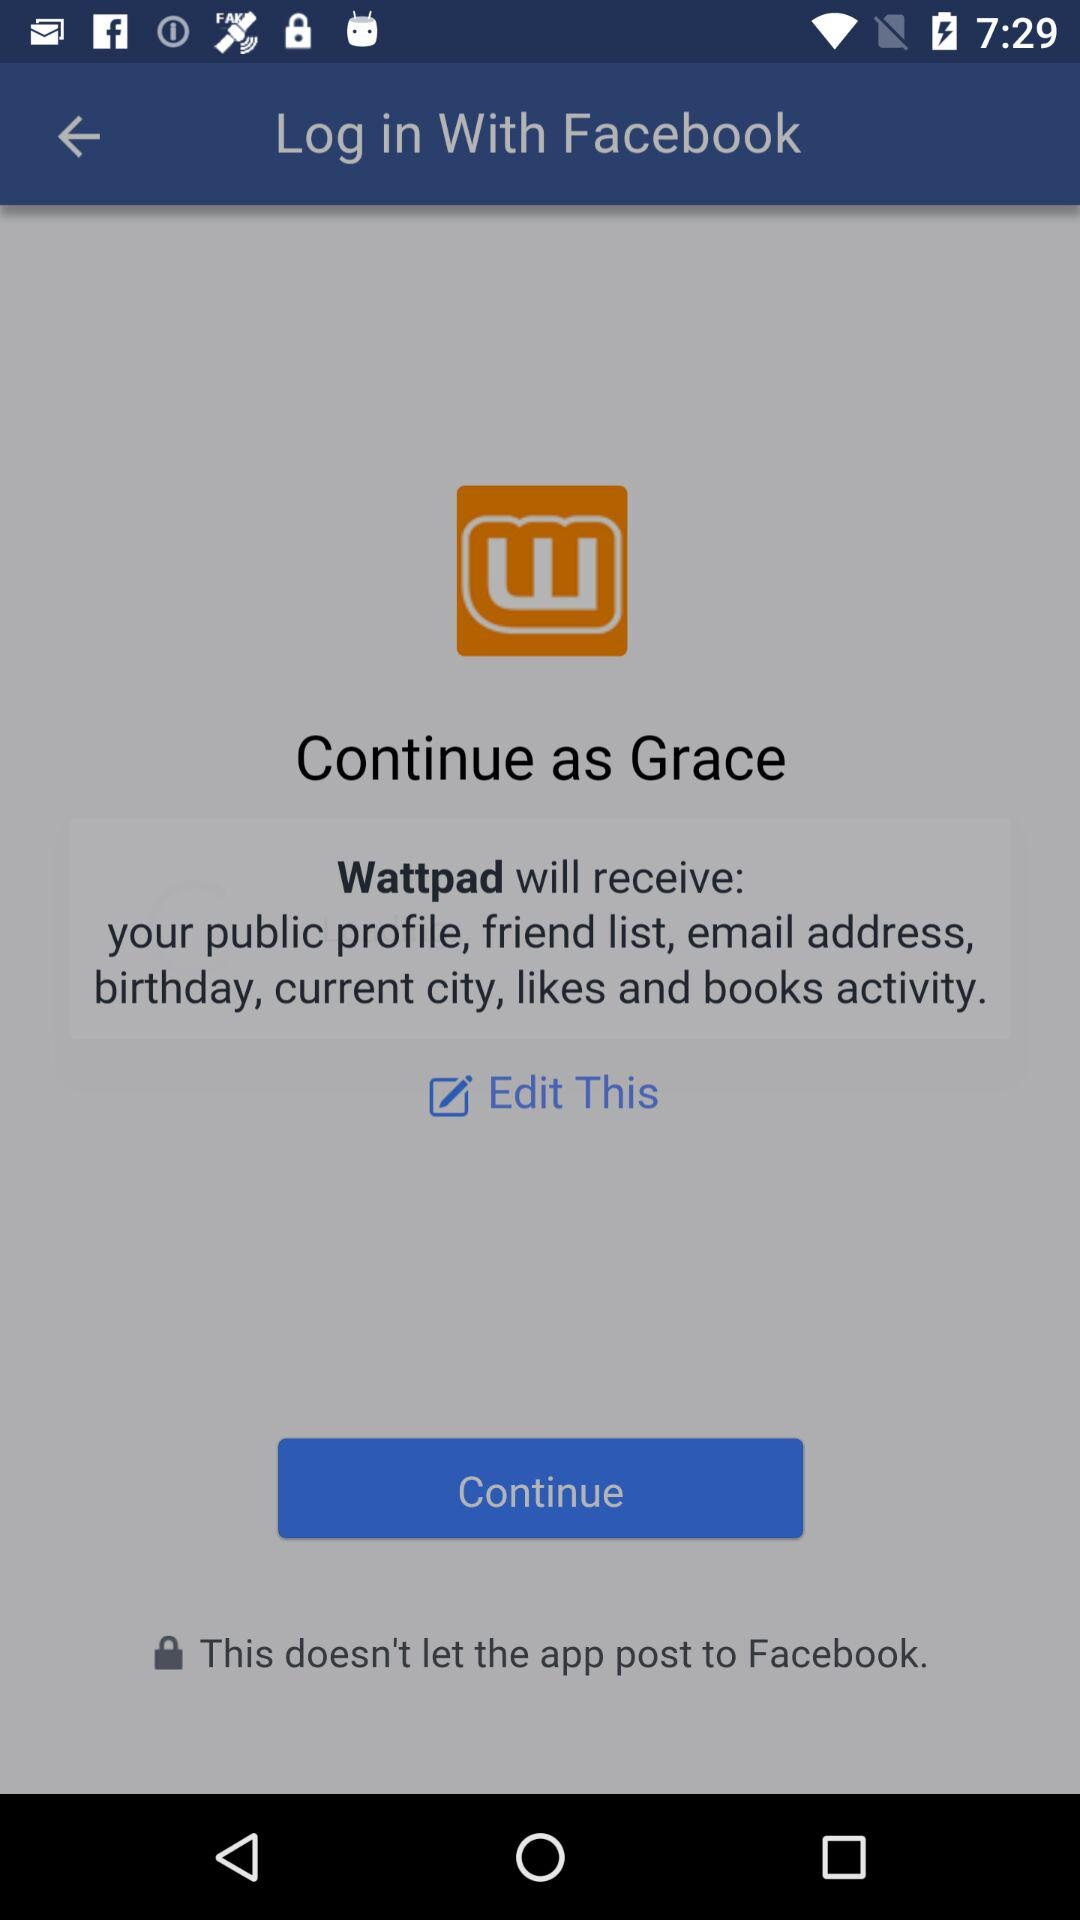What application is asking for permission? The application that is asking for permission is "Wattpad". 